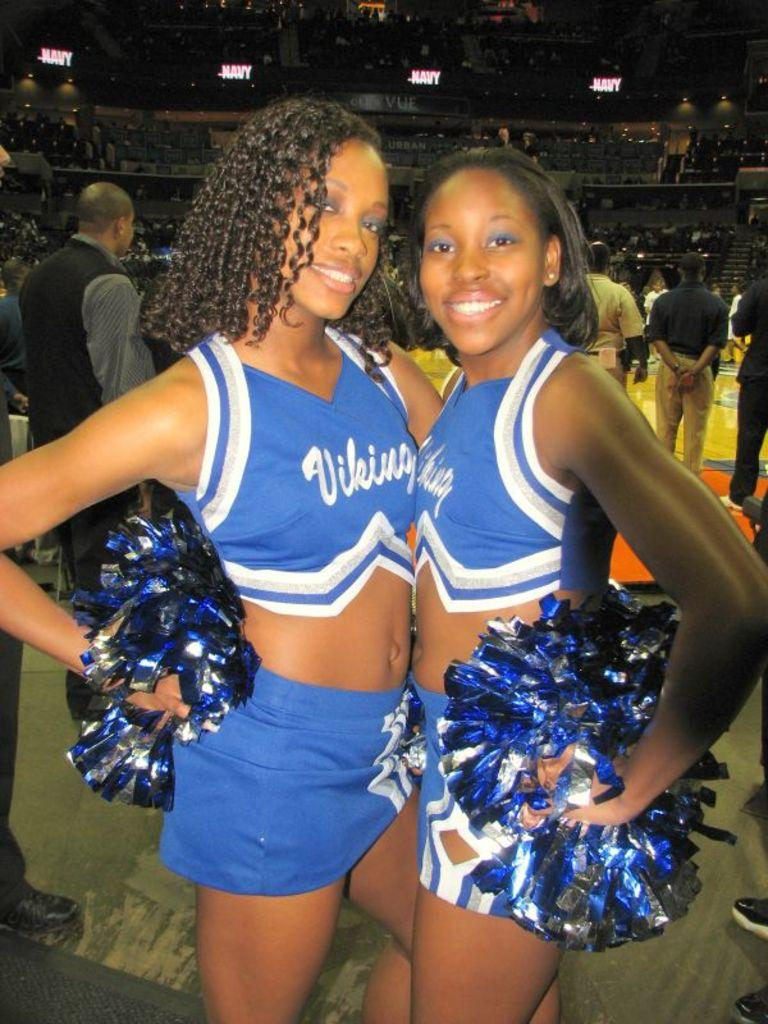<image>
Create a compact narrative representing the image presented. a couple of cheerleaders that are wearing Vikings on their outfit 